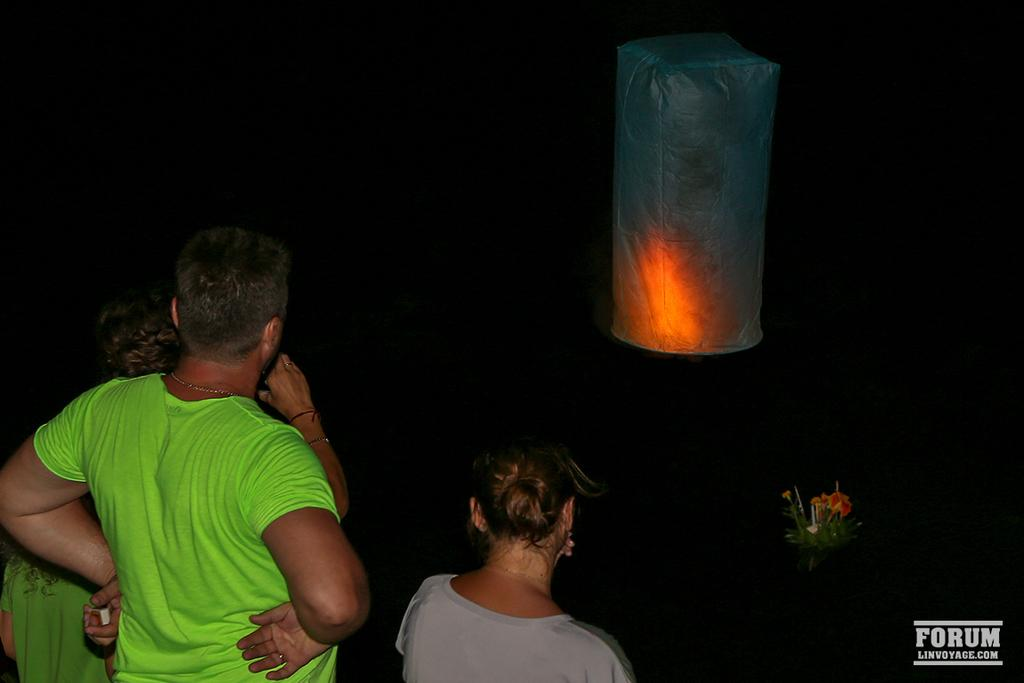What can be seen on the left side of the image? There are people standing at the left side of the image. What is located on the right side of the image? There is a white color object at the right side of the image. Can you tell me how many receipts are visible in the image? There is no mention of receipts in the provided facts, so it cannot be determined if any are present in the image. 